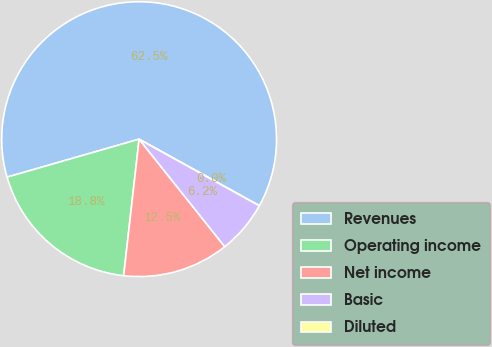Convert chart to OTSL. <chart><loc_0><loc_0><loc_500><loc_500><pie_chart><fcel>Revenues<fcel>Operating income<fcel>Net income<fcel>Basic<fcel>Diluted<nl><fcel>62.5%<fcel>18.75%<fcel>12.5%<fcel>6.25%<fcel>0.0%<nl></chart> 